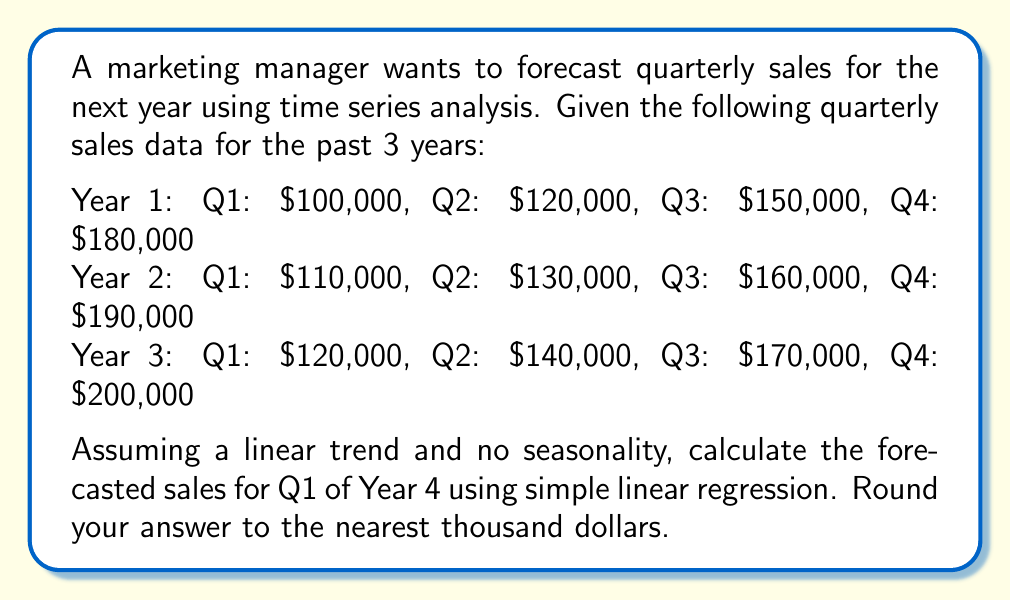Provide a solution to this math problem. To forecast sales using simple linear regression, we'll follow these steps:

1. Assign time periods to each quarter:
   Q1 Year 1 = 1, Q2 Year 1 = 2, ..., Q4 Year 3 = 12

2. Calculate the mean of time periods (x) and sales (y):
   $\bar{x} = \frac{1 + 2 + ... + 12}{12} = 6.5$
   $\bar{y} = \frac{100,000 + 120,000 + ... + 200,000}{12} = 147,500$

3. Calculate the slope (b) using the formula:
   $b = \frac{\sum(x - \bar{x})(y - \bar{y})}{\sum(x - \bar{x})^2}$

   $\sum(x - \bar{x})^2 = (-5.5)^2 + (-4.5)^2 + ... + (5.5)^2 = 143$

   $\sum(x - \bar{x})(y - \bar{y}) = (-5.5)(-47,500) + (-4.5)(-27,500) + ... + (5.5)(52,500) = 1,430,000$

   $b = \frac{1,430,000}{143} = 10,000$

4. Calculate the y-intercept (a) using the formula:
   $a = \bar{y} - b\bar{x} = 147,500 - 10,000(6.5) = 82,500$

5. Use the linear regression equation to forecast Q1 of Year 4 (x = 13):
   $y = a + bx = 82,500 + 10,000(13) = 212,500$

6. Round the result to the nearest thousand dollars:
   $212,500 ≈ 213,000$
Answer: $213,000 